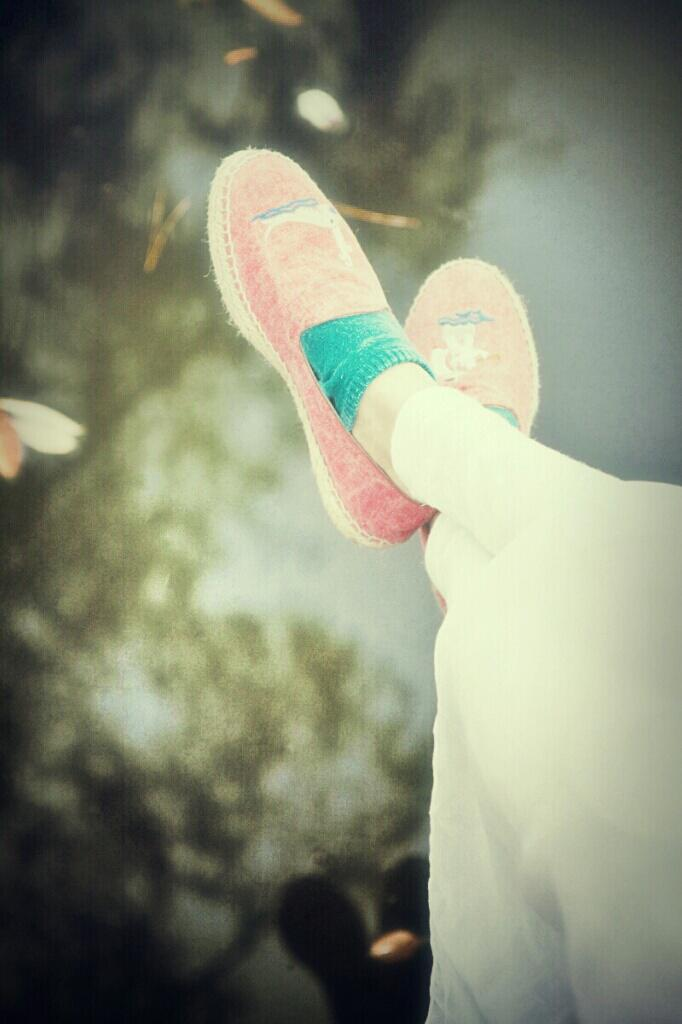What part of a person can be seen in the image? There are legs of a person visible in the image. What type of footwear is the person wearing? The person is wearing shoes. Can you describe the background of the image? The background of the image is blurred. What type of badge is the person wearing in the image? There is no badge visible in the image. What is the mass of the person in the image? The mass of the person cannot be determined from the image. 